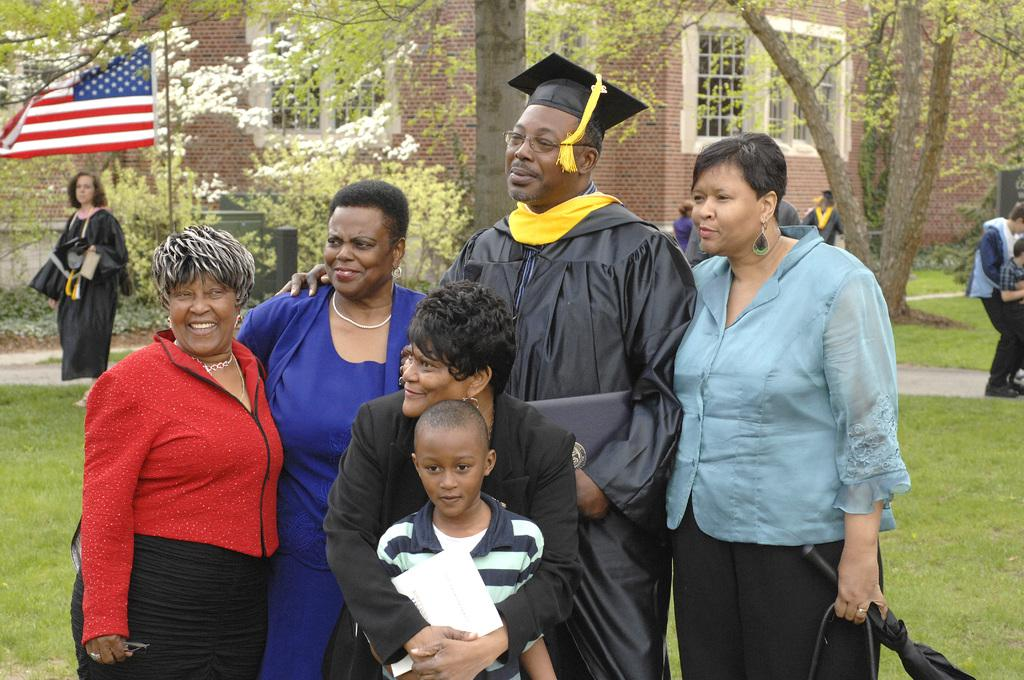What can be observed about the people in the image? There are people standing in the image, and some of them have smiles on their faces. What is visible in the background of the image? There is a building, windows, trees, and a flag visible in the background. What type of wealth is displayed by the people in the image? There is no indication of wealth in the image; it only shows people standing and smiling. How does the railway system connect with the people in the image? There is no railway system present in the image. 